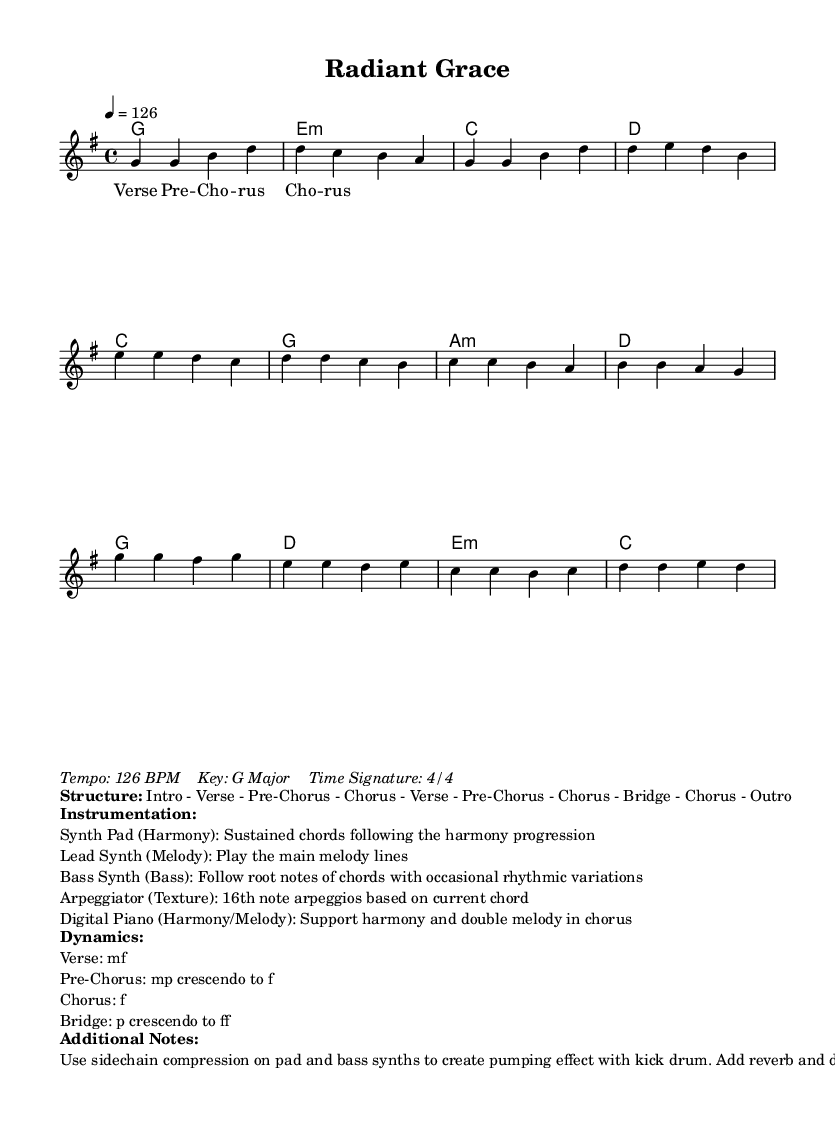What is the key signature of this music? The key signature is G major, which has one sharp (F#). It can be identified by looking at the key signature indicated at the beginning of the sheet music.
Answer: G major What is the time signature of the piece? The time signature is 4/4, which is common in contemporary worship music. It indicates that there are four beats in each measure and the quarter note gets one beat.
Answer: 4/4 What is the tempo marking for this composition? The tempo marking is 126 BPM, which is indicated at the beginning of the score. BPM stands for beats per minute, showing the speed of the piece.
Answer: 126 BPM How many sections does the music have? The music has six main sections: Intro, Verse, Pre-Chorus, Chorus, Bridge, and Outro. This is determined by analyzing the structure provided at the bottom of the music sheet, which outlines the form.
Answer: 6 sections What dynamics are indicated for the Chorus? The dynamics for the Chorus indicate 'f' which stands for fortissimo, meaning to play very loudly. This can be found in the dynamics markings next to the sections of the music.
Answer: f What instrumentation is suggested for the arpeggiator? The arpeggiator is suggested to play 16th note arpeggios based on the current chord. This information is detailed in the instrumentation section of the sheet music.
Answer: 16th note arpeggios What expressive technique is recommended for the synth pad and bass synths? It is recommended to use sidechain compression on the pad and bass synths. This technique creates a pumping effect with the kick drum, as noted in the additional notes section of the score.
Answer: Sidechain compression 